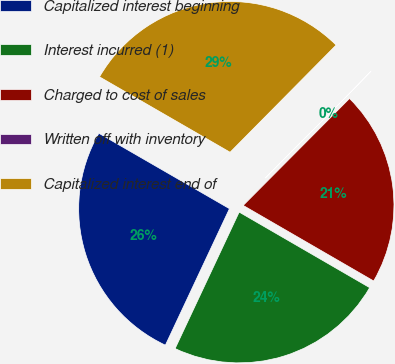Convert chart to OTSL. <chart><loc_0><loc_0><loc_500><loc_500><pie_chart><fcel>Capitalized interest beginning<fcel>Interest incurred (1)<fcel>Charged to cost of sales<fcel>Written off with inventory<fcel>Capitalized interest end of<nl><fcel>26.35%<fcel>23.63%<fcel>20.9%<fcel>0.04%<fcel>29.08%<nl></chart> 